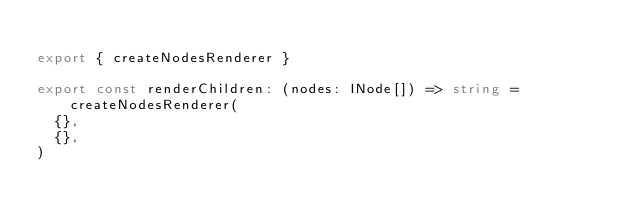Convert code to text. <code><loc_0><loc_0><loc_500><loc_500><_TypeScript_>
export { createNodesRenderer }

export const renderChildren: (nodes: INode[]) => string = createNodesRenderer(
  {},
  {},
)
</code> 